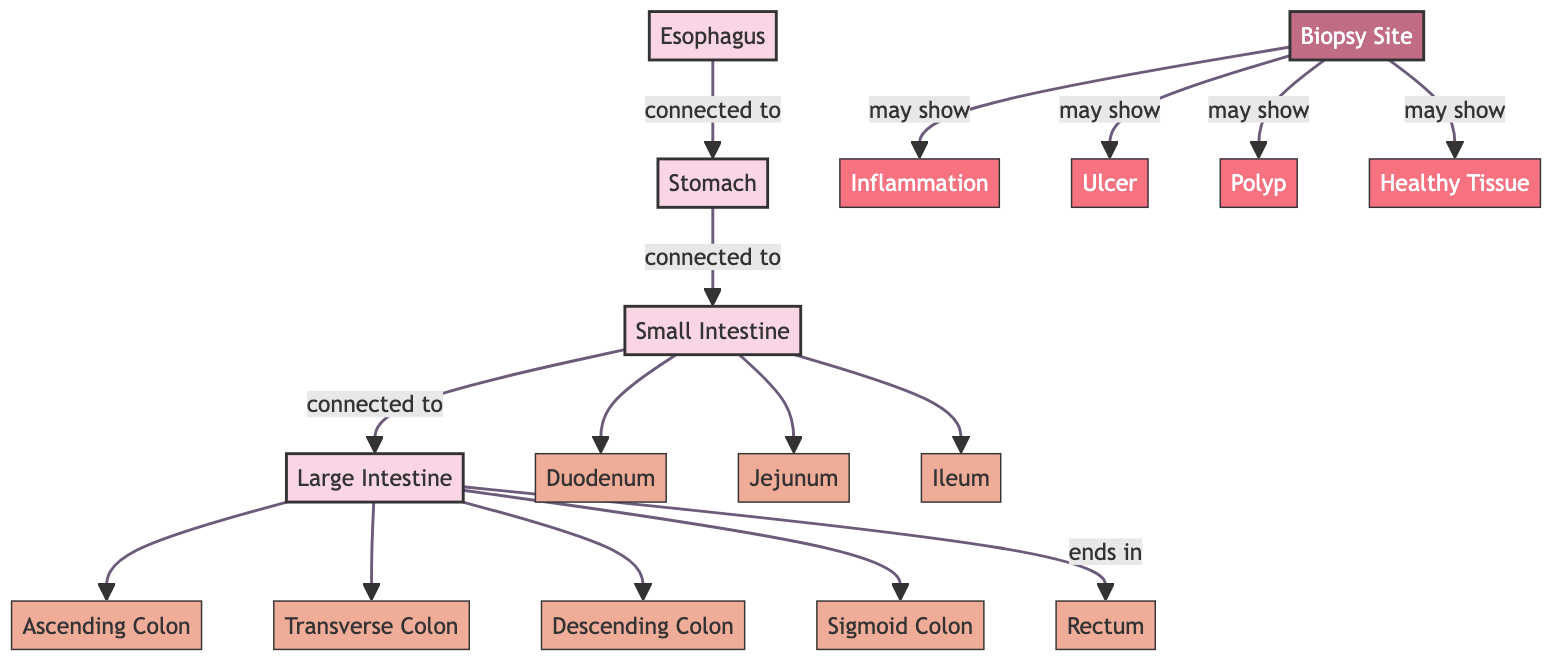What organs are connected in the gastrointestinal tract? The diagram shows the connections between the esophagus, stomach, small intestine, and large intestine. Each organ is linked sequentially, starting from the esophagus down to the large intestine.
Answer: Esophagus, stomach, small intestine, large intestine How many parts are there in the small intestine? The small intestine consists of three distinct parts: the duodenum, jejunum, and ileum. These are explicitly labeled in the diagram as separate entities.
Answer: Three What findings may be observed at the biopsy site? The diagram indicates several possible findings at the biopsy site, including inflammation, ulcer, polyp, and healthy tissue. Each finding is connected to the biopsy site node.
Answer: Inflammation, ulcer, polyp, healthy tissue Which part of the large intestine comes after the ascending colon? According to the diagram, the ascending colon connects to the transverse colon. The connections illustrated indicate the sequence of parts within the large intestine.
Answer: Transverse Colon What is the last part of the large intestine depicted in the diagram? The diagram shows that the large intestine ends in the rectum, which is the final node connected to the series of large intestine parts.
Answer: Rectum What may be revealed by a biopsy site showing inflammation? Inflammation, as depicted in the diagram, is one of the potential indications that can be observed at the biopsy site, highlighting a possible health issue.
Answer: Inflammation How many total organs are displayed in the gastrointestinal tract? The diagram distinctly shows a total of four main organs: the esophagus, stomach, small intestine, and large intestine, indicating their major roles in the digestive system.
Answer: Four Which part of the small intestine comes after the duodenum? The diagram indicates that the jejunum follows the duodenum as part of the small intestine's flow, showing the order of these sections.
Answer: Jejunum What type of findings can a biopsy site indicate in addition to healthy tissue? Aside from healthy tissue, the biopsy site may indicate inflammation, ulcers, or polyps, all of which highlight potential problems in the gastrointestinal tract based on the diagram connections.
Answer: Inflammation, ulcer, polyp 